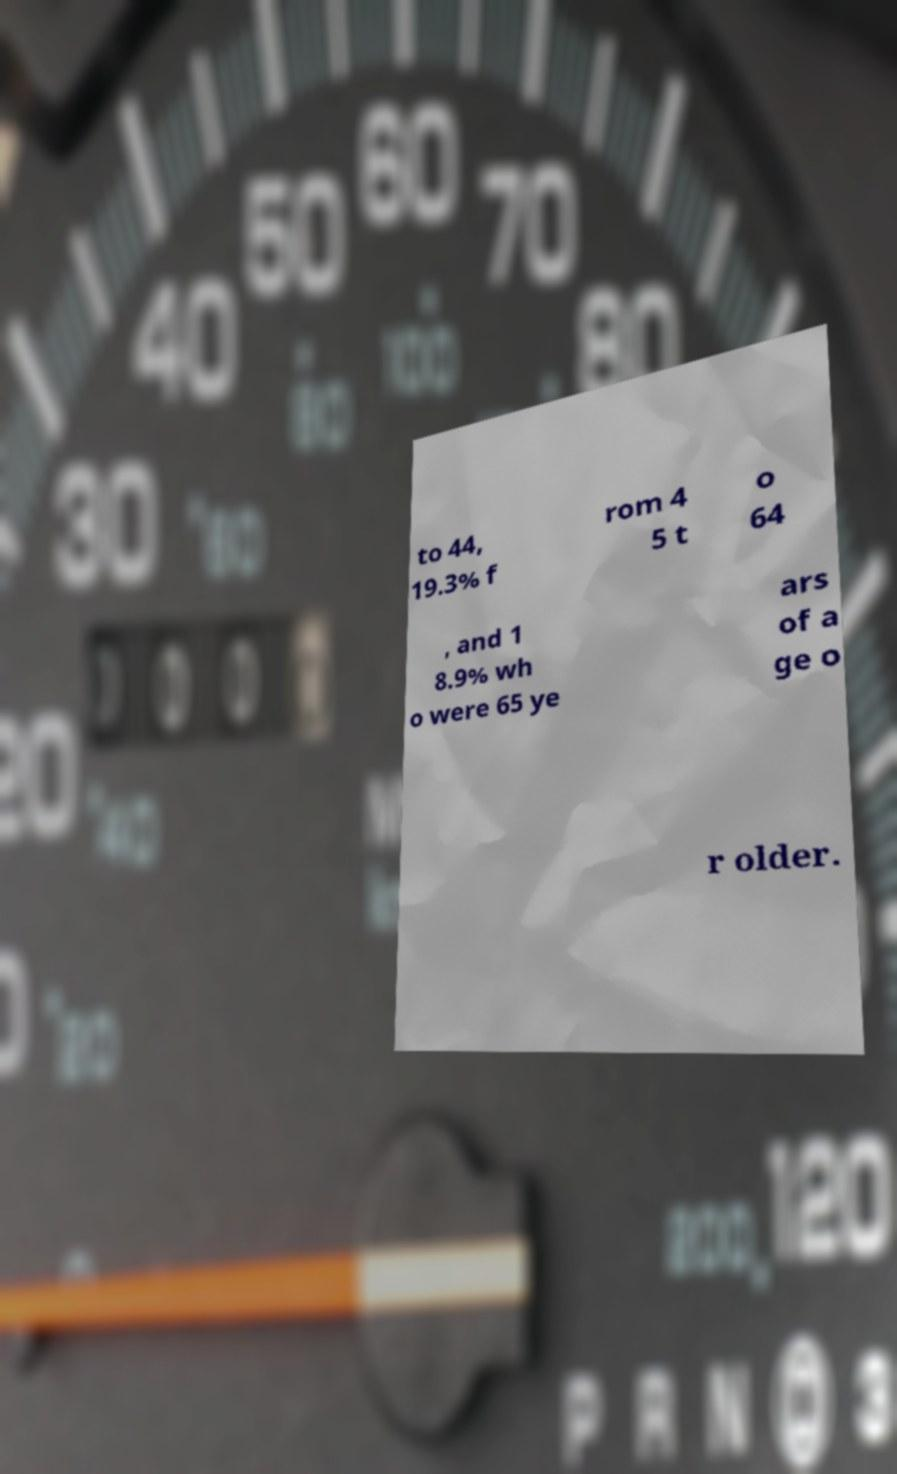I need the written content from this picture converted into text. Can you do that? to 44, 19.3% f rom 4 5 t o 64 , and 1 8.9% wh o were 65 ye ars of a ge o r older. 